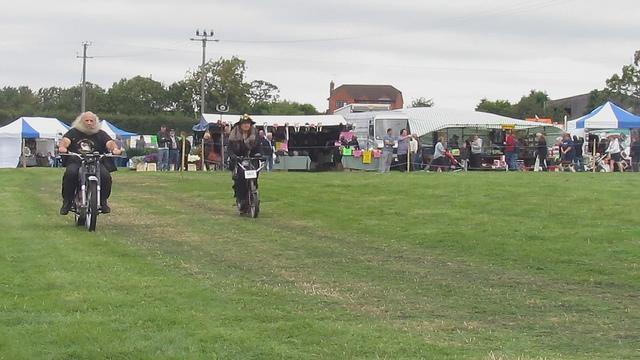How many people are there?
Give a very brief answer. 2. 